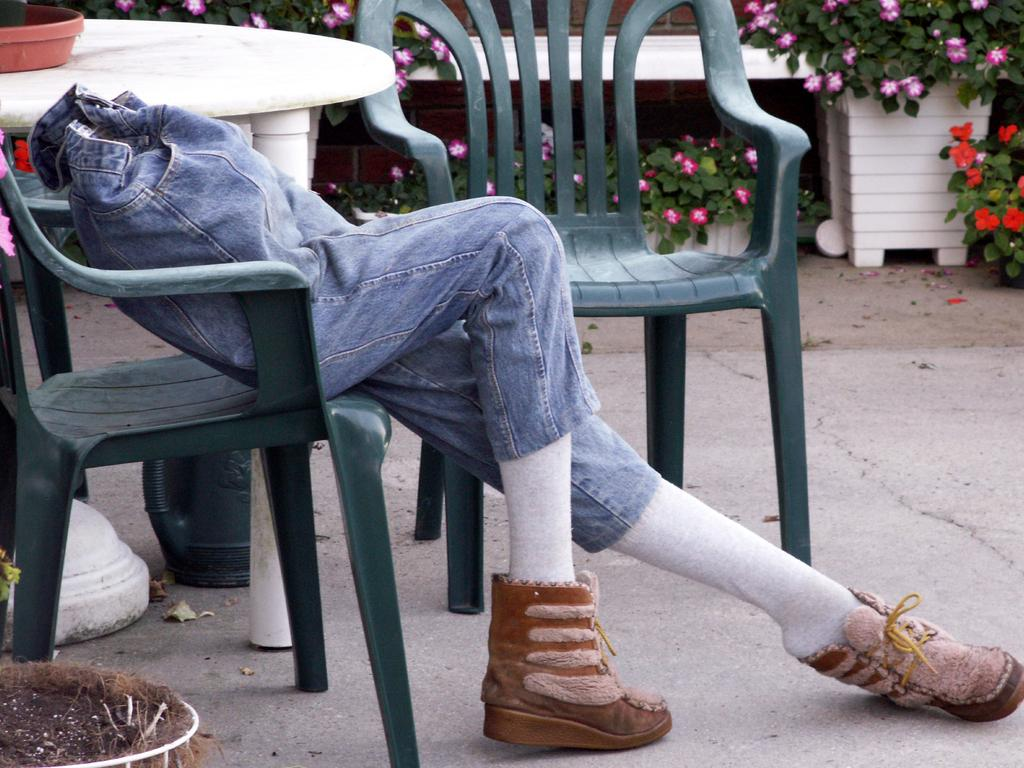What piece of furniture is present in the image? There is a table in the image. What is the mannequin doing in the image? The mannequin is sitting on a chair in the image. What type of decorative items can be seen in the image? There are flower pots at the back side of the image. What type of joke is the mannequin telling in the image? There is no joke being told in the image, as the mannequin is simply sitting on a chair. How does the monkey transport the flower pots in the image? There is no monkey present in the image, so it cannot transport the flower pots. 